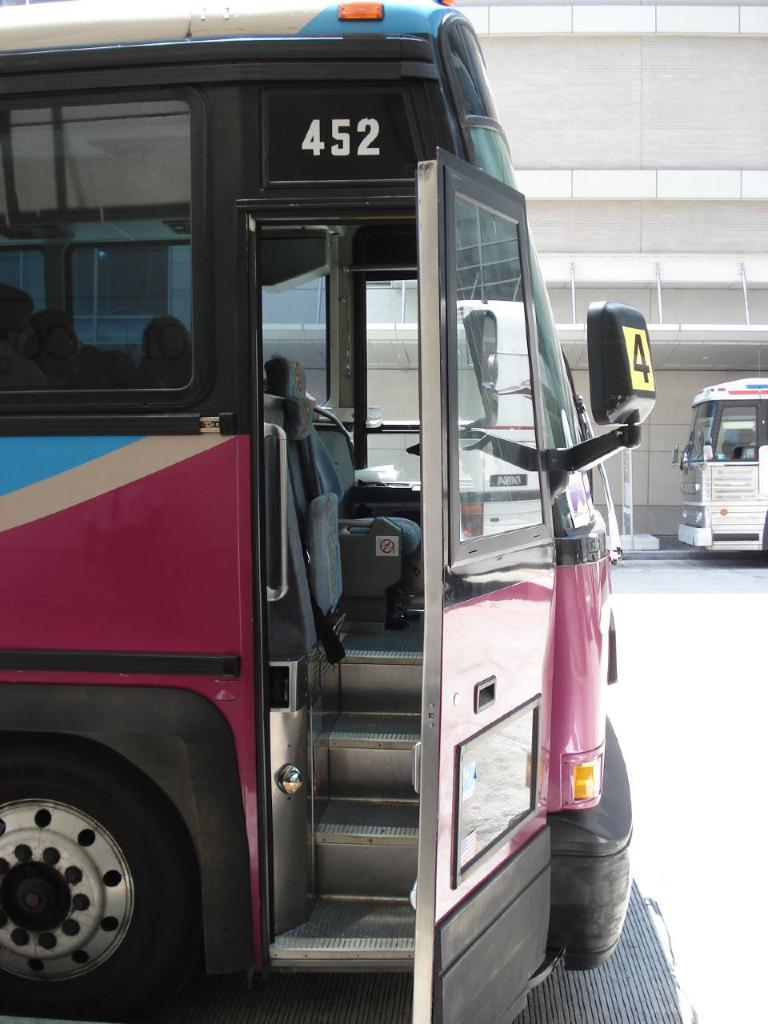Provide a one-sentence caption for the provided image. Bus number 452 is parked with its door open. 